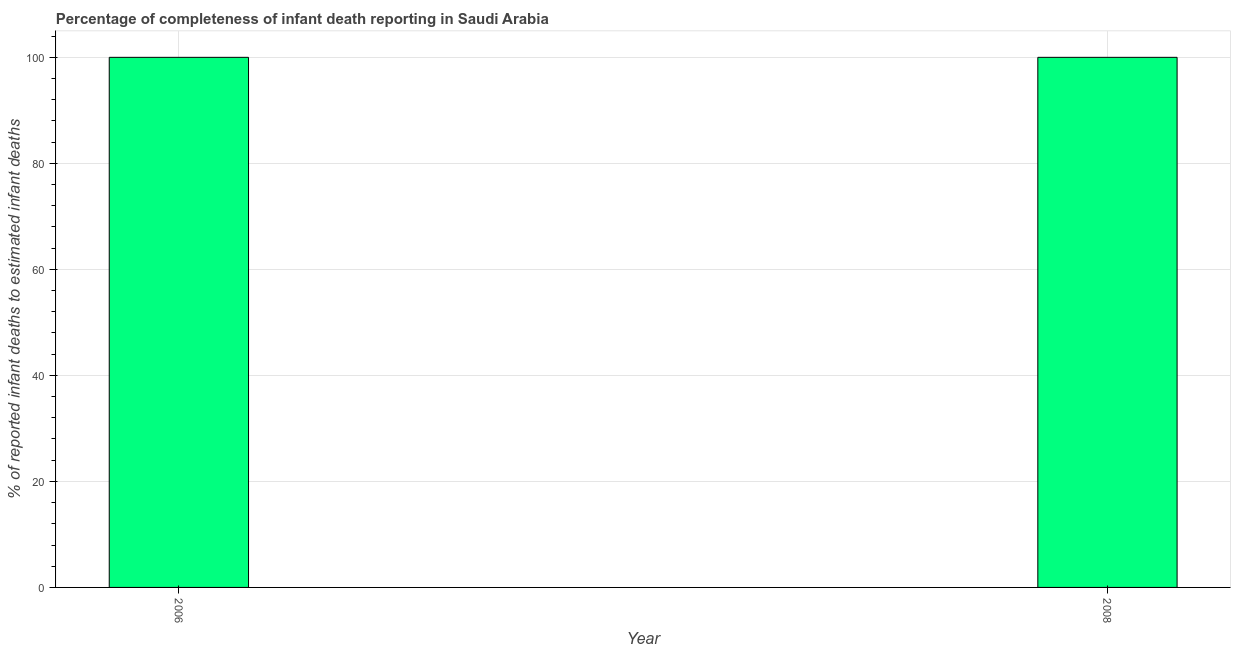Does the graph contain any zero values?
Ensure brevity in your answer.  No. Does the graph contain grids?
Your answer should be compact. Yes. What is the title of the graph?
Offer a terse response. Percentage of completeness of infant death reporting in Saudi Arabia. What is the label or title of the X-axis?
Offer a terse response. Year. What is the label or title of the Y-axis?
Offer a very short reply. % of reported infant deaths to estimated infant deaths. Across all years, what is the maximum completeness of infant death reporting?
Offer a very short reply. 100. In which year was the completeness of infant death reporting maximum?
Your answer should be very brief. 2006. In which year was the completeness of infant death reporting minimum?
Give a very brief answer. 2006. What is the sum of the completeness of infant death reporting?
Provide a short and direct response. 200. What is the difference between the completeness of infant death reporting in 2006 and 2008?
Keep it short and to the point. 0. What is the average completeness of infant death reporting per year?
Offer a terse response. 100. In how many years, is the completeness of infant death reporting greater than 28 %?
Make the answer very short. 2. Is the completeness of infant death reporting in 2006 less than that in 2008?
Your answer should be compact. No. In how many years, is the completeness of infant death reporting greater than the average completeness of infant death reporting taken over all years?
Your answer should be very brief. 0. How many years are there in the graph?
Your response must be concise. 2. Are the values on the major ticks of Y-axis written in scientific E-notation?
Make the answer very short. No. What is the % of reported infant deaths to estimated infant deaths in 2006?
Offer a very short reply. 100. What is the difference between the % of reported infant deaths to estimated infant deaths in 2006 and 2008?
Ensure brevity in your answer.  0. What is the ratio of the % of reported infant deaths to estimated infant deaths in 2006 to that in 2008?
Offer a very short reply. 1. 